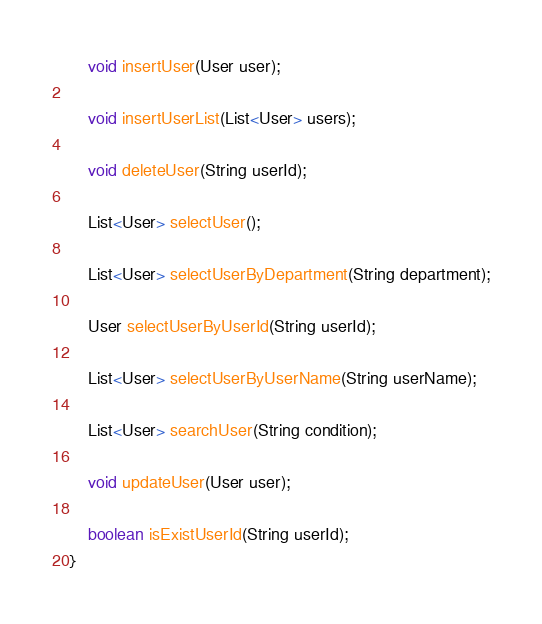<code> <loc_0><loc_0><loc_500><loc_500><_Java_>
    void insertUser(User user);

    void insertUserList(List<User> users);

    void deleteUser(String userId);

    List<User> selectUser();

    List<User> selectUserByDepartment(String department);

    User selectUserByUserId(String userId);

    List<User> selectUserByUserName(String userName);

    List<User> searchUser(String condition);

    void updateUser(User user);

    boolean isExistUserId(String userId);
}
</code> 